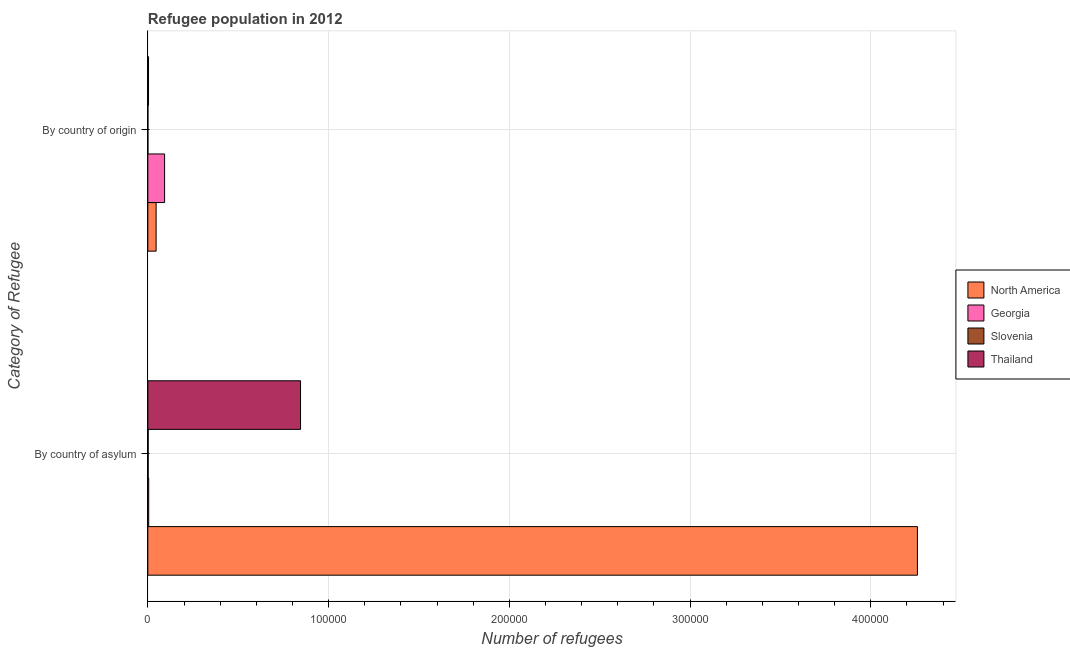How many different coloured bars are there?
Your answer should be compact. 4. Are the number of bars on each tick of the Y-axis equal?
Your response must be concise. Yes. What is the label of the 1st group of bars from the top?
Offer a terse response. By country of origin. What is the number of refugees by country of asylum in Georgia?
Your response must be concise. 469. Across all countries, what is the maximum number of refugees by country of origin?
Provide a succinct answer. 9261. Across all countries, what is the minimum number of refugees by country of asylum?
Keep it short and to the point. 176. In which country was the number of refugees by country of origin maximum?
Make the answer very short. Georgia. In which country was the number of refugees by country of asylum minimum?
Ensure brevity in your answer.  Slovenia. What is the total number of refugees by country of origin in the graph?
Provide a succinct answer. 1.43e+04. What is the difference between the number of refugees by country of asylum in Thailand and that in Georgia?
Offer a very short reply. 8.40e+04. What is the difference between the number of refugees by country of asylum in Georgia and the number of refugees by country of origin in North America?
Your answer should be very brief. -4110. What is the average number of refugees by country of asylum per country?
Your response must be concise. 1.28e+05. What is the difference between the number of refugees by country of origin and number of refugees by country of asylum in Georgia?
Your answer should be compact. 8792. In how many countries, is the number of refugees by country of origin greater than 400000 ?
Your answer should be very brief. 0. What is the ratio of the number of refugees by country of asylum in North America to that in Slovenia?
Your answer should be compact. 2419.2. What does the 1st bar from the top in By country of origin represents?
Ensure brevity in your answer.  Thailand. What does the 2nd bar from the bottom in By country of origin represents?
Your answer should be compact. Georgia. Are all the bars in the graph horizontal?
Your answer should be very brief. Yes. How many countries are there in the graph?
Make the answer very short. 4. Does the graph contain grids?
Make the answer very short. Yes. Where does the legend appear in the graph?
Offer a terse response. Center right. What is the title of the graph?
Provide a short and direct response. Refugee population in 2012. What is the label or title of the X-axis?
Offer a terse response. Number of refugees. What is the label or title of the Y-axis?
Your answer should be very brief. Category of Refugee. What is the Number of refugees in North America in By country of asylum?
Your answer should be very brief. 4.26e+05. What is the Number of refugees of Georgia in By country of asylum?
Your response must be concise. 469. What is the Number of refugees in Slovenia in By country of asylum?
Make the answer very short. 176. What is the Number of refugees in Thailand in By country of asylum?
Keep it short and to the point. 8.45e+04. What is the Number of refugees in North America in By country of origin?
Offer a very short reply. 4579. What is the Number of refugees in Georgia in By country of origin?
Provide a succinct answer. 9261. What is the Number of refugees of Thailand in By country of origin?
Ensure brevity in your answer.  381. Across all Category of Refugee, what is the maximum Number of refugees in North America?
Provide a succinct answer. 4.26e+05. Across all Category of Refugee, what is the maximum Number of refugees of Georgia?
Make the answer very short. 9261. Across all Category of Refugee, what is the maximum Number of refugees of Slovenia?
Your answer should be compact. 176. Across all Category of Refugee, what is the maximum Number of refugees in Thailand?
Keep it short and to the point. 8.45e+04. Across all Category of Refugee, what is the minimum Number of refugees of North America?
Ensure brevity in your answer.  4579. Across all Category of Refugee, what is the minimum Number of refugees of Georgia?
Provide a succinct answer. 469. Across all Category of Refugee, what is the minimum Number of refugees in Thailand?
Make the answer very short. 381. What is the total Number of refugees of North America in the graph?
Offer a terse response. 4.30e+05. What is the total Number of refugees of Georgia in the graph?
Ensure brevity in your answer.  9730. What is the total Number of refugees of Slovenia in the graph?
Your answer should be very brief. 210. What is the total Number of refugees of Thailand in the graph?
Offer a very short reply. 8.49e+04. What is the difference between the Number of refugees in North America in By country of asylum and that in By country of origin?
Give a very brief answer. 4.21e+05. What is the difference between the Number of refugees in Georgia in By country of asylum and that in By country of origin?
Make the answer very short. -8792. What is the difference between the Number of refugees of Slovenia in By country of asylum and that in By country of origin?
Provide a succinct answer. 142. What is the difference between the Number of refugees in Thailand in By country of asylum and that in By country of origin?
Ensure brevity in your answer.  8.41e+04. What is the difference between the Number of refugees of North America in By country of asylum and the Number of refugees of Georgia in By country of origin?
Your answer should be compact. 4.17e+05. What is the difference between the Number of refugees in North America in By country of asylum and the Number of refugees in Slovenia in By country of origin?
Make the answer very short. 4.26e+05. What is the difference between the Number of refugees in North America in By country of asylum and the Number of refugees in Thailand in By country of origin?
Offer a terse response. 4.25e+05. What is the difference between the Number of refugees in Georgia in By country of asylum and the Number of refugees in Slovenia in By country of origin?
Provide a succinct answer. 435. What is the difference between the Number of refugees of Slovenia in By country of asylum and the Number of refugees of Thailand in By country of origin?
Offer a very short reply. -205. What is the average Number of refugees in North America per Category of Refugee?
Give a very brief answer. 2.15e+05. What is the average Number of refugees of Georgia per Category of Refugee?
Offer a very short reply. 4865. What is the average Number of refugees of Slovenia per Category of Refugee?
Give a very brief answer. 105. What is the average Number of refugees in Thailand per Category of Refugee?
Your answer should be compact. 4.24e+04. What is the difference between the Number of refugees in North America and Number of refugees in Georgia in By country of asylum?
Offer a terse response. 4.25e+05. What is the difference between the Number of refugees of North America and Number of refugees of Slovenia in By country of asylum?
Offer a terse response. 4.26e+05. What is the difference between the Number of refugees of North America and Number of refugees of Thailand in By country of asylum?
Provide a succinct answer. 3.41e+05. What is the difference between the Number of refugees of Georgia and Number of refugees of Slovenia in By country of asylum?
Offer a very short reply. 293. What is the difference between the Number of refugees in Georgia and Number of refugees in Thailand in By country of asylum?
Keep it short and to the point. -8.40e+04. What is the difference between the Number of refugees in Slovenia and Number of refugees in Thailand in By country of asylum?
Keep it short and to the point. -8.43e+04. What is the difference between the Number of refugees in North America and Number of refugees in Georgia in By country of origin?
Your answer should be very brief. -4682. What is the difference between the Number of refugees in North America and Number of refugees in Slovenia in By country of origin?
Your response must be concise. 4545. What is the difference between the Number of refugees of North America and Number of refugees of Thailand in By country of origin?
Provide a short and direct response. 4198. What is the difference between the Number of refugees in Georgia and Number of refugees in Slovenia in By country of origin?
Provide a short and direct response. 9227. What is the difference between the Number of refugees of Georgia and Number of refugees of Thailand in By country of origin?
Provide a succinct answer. 8880. What is the difference between the Number of refugees of Slovenia and Number of refugees of Thailand in By country of origin?
Your answer should be compact. -347. What is the ratio of the Number of refugees of North America in By country of asylum to that in By country of origin?
Your answer should be very brief. 92.99. What is the ratio of the Number of refugees in Georgia in By country of asylum to that in By country of origin?
Your answer should be very brief. 0.05. What is the ratio of the Number of refugees of Slovenia in By country of asylum to that in By country of origin?
Your answer should be compact. 5.18. What is the ratio of the Number of refugees of Thailand in By country of asylum to that in By country of origin?
Ensure brevity in your answer.  221.73. What is the difference between the highest and the second highest Number of refugees in North America?
Make the answer very short. 4.21e+05. What is the difference between the highest and the second highest Number of refugees of Georgia?
Your response must be concise. 8792. What is the difference between the highest and the second highest Number of refugees in Slovenia?
Provide a succinct answer. 142. What is the difference between the highest and the second highest Number of refugees in Thailand?
Your answer should be compact. 8.41e+04. What is the difference between the highest and the lowest Number of refugees of North America?
Ensure brevity in your answer.  4.21e+05. What is the difference between the highest and the lowest Number of refugees in Georgia?
Your answer should be compact. 8792. What is the difference between the highest and the lowest Number of refugees of Slovenia?
Your answer should be very brief. 142. What is the difference between the highest and the lowest Number of refugees in Thailand?
Give a very brief answer. 8.41e+04. 